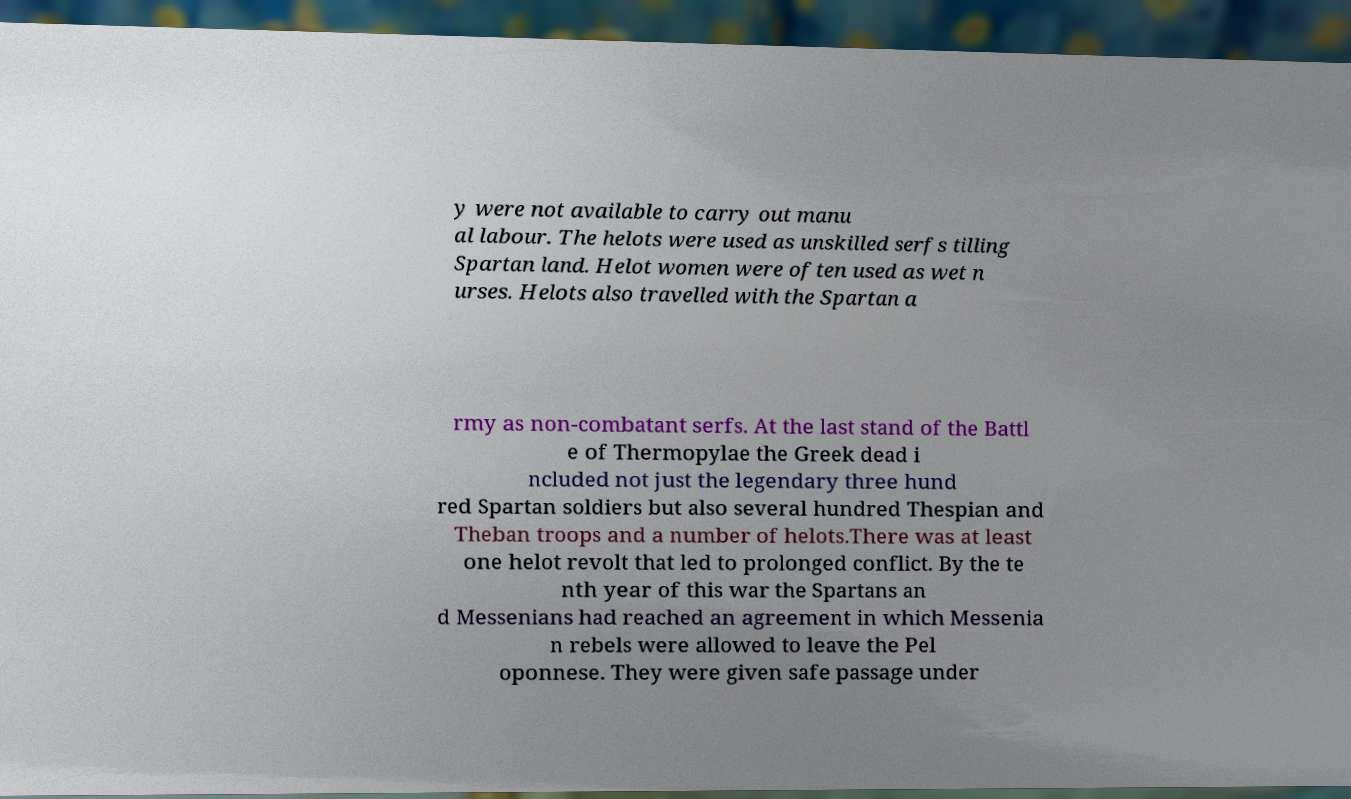What messages or text are displayed in this image? I need them in a readable, typed format. y were not available to carry out manu al labour. The helots were used as unskilled serfs tilling Spartan land. Helot women were often used as wet n urses. Helots also travelled with the Spartan a rmy as non-combatant serfs. At the last stand of the Battl e of Thermopylae the Greek dead i ncluded not just the legendary three hund red Spartan soldiers but also several hundred Thespian and Theban troops and a number of helots.There was at least one helot revolt that led to prolonged conflict. By the te nth year of this war the Spartans an d Messenians had reached an agreement in which Messenia n rebels were allowed to leave the Pel oponnese. They were given safe passage under 